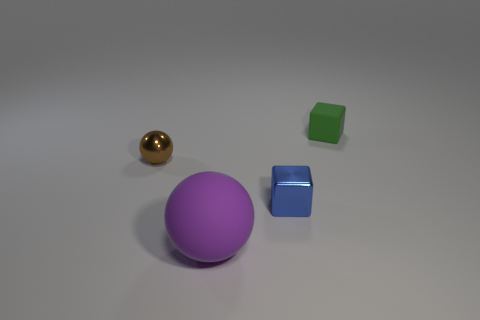Add 3 small shiny objects. How many objects exist? 7 Add 4 tiny green objects. How many tiny green objects exist? 5 Subtract 0 yellow cubes. How many objects are left? 4 Subtract all big yellow metal blocks. Subtract all brown balls. How many objects are left? 3 Add 2 large balls. How many large balls are left? 3 